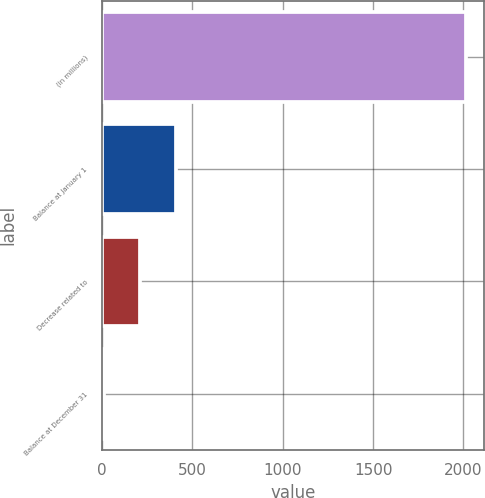Convert chart to OTSL. <chart><loc_0><loc_0><loc_500><loc_500><bar_chart><fcel>(in millions)<fcel>Balance at January 1<fcel>Decrease related to<fcel>Balance at December 31<nl><fcel>2013<fcel>411.4<fcel>211.2<fcel>11<nl></chart> 